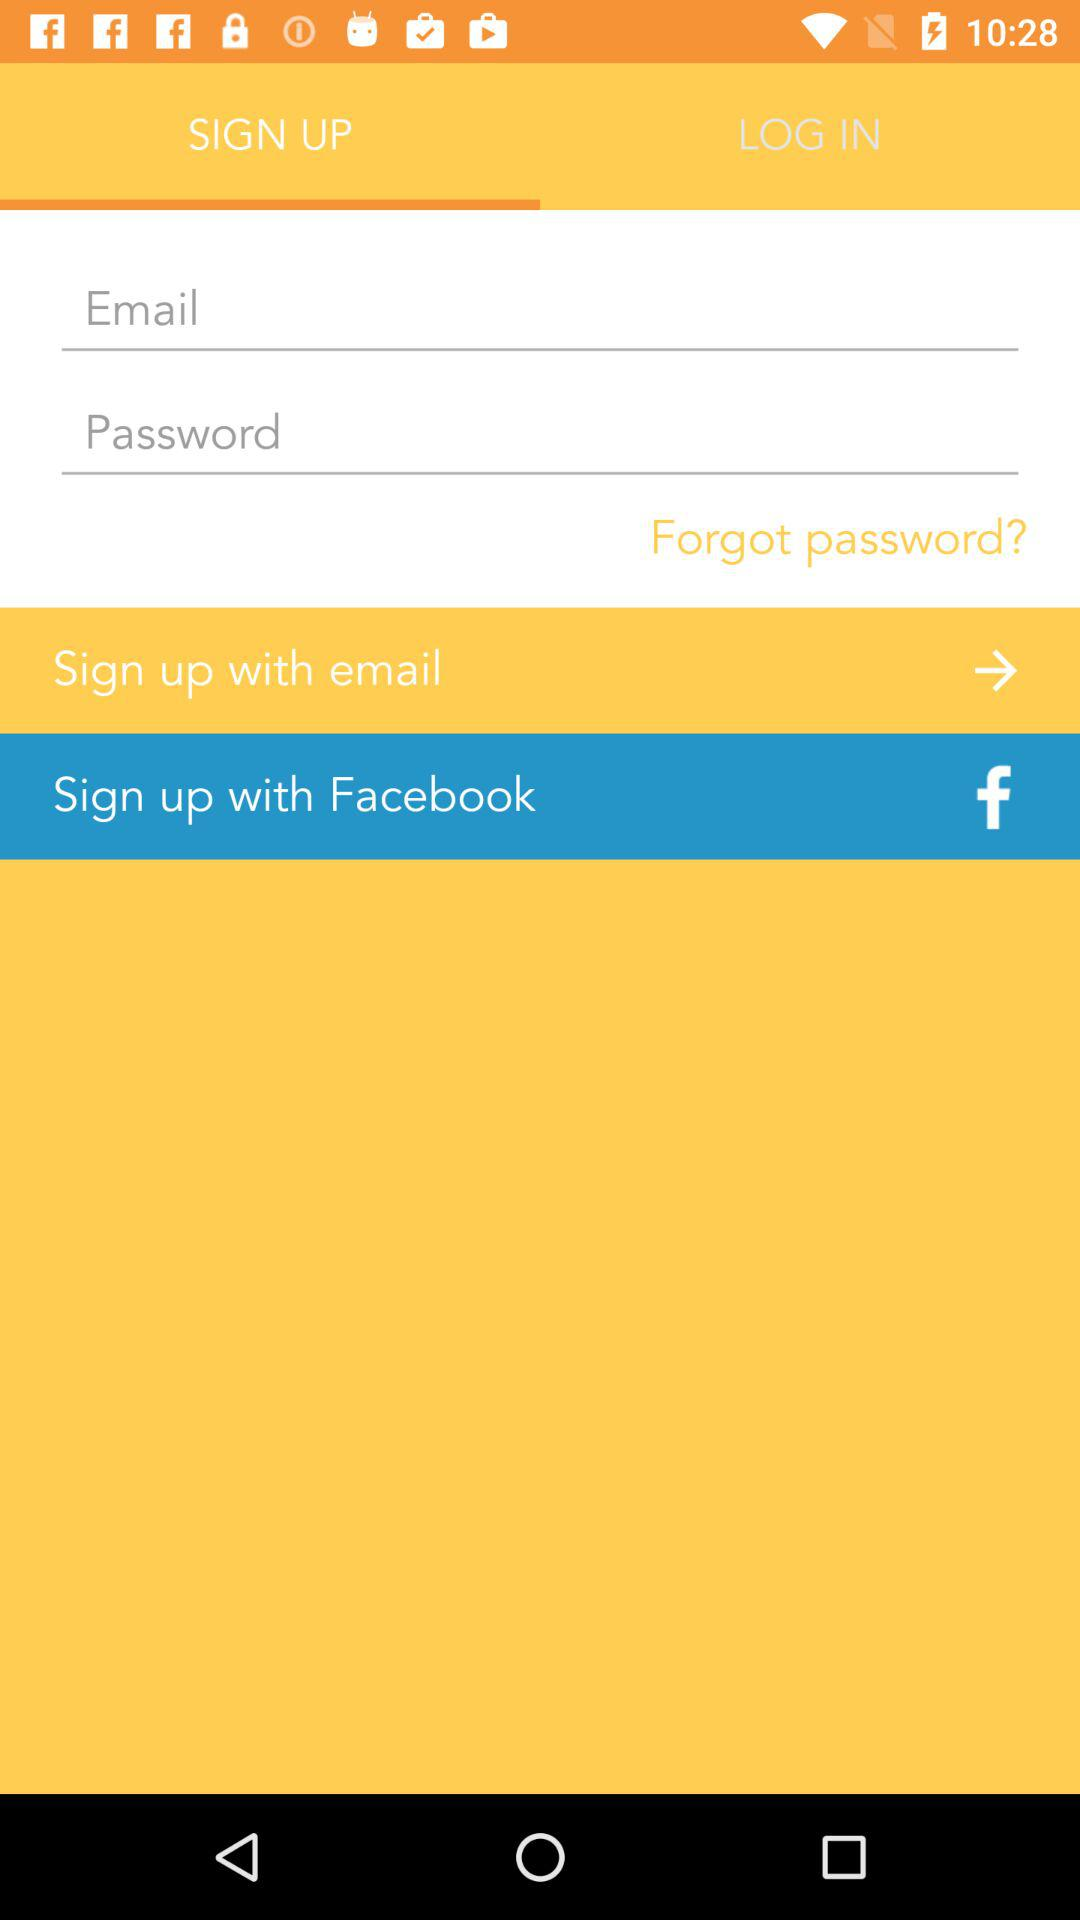What are the options through which we can sign up? The options through which you can sign up are "email" and "Facebook". 